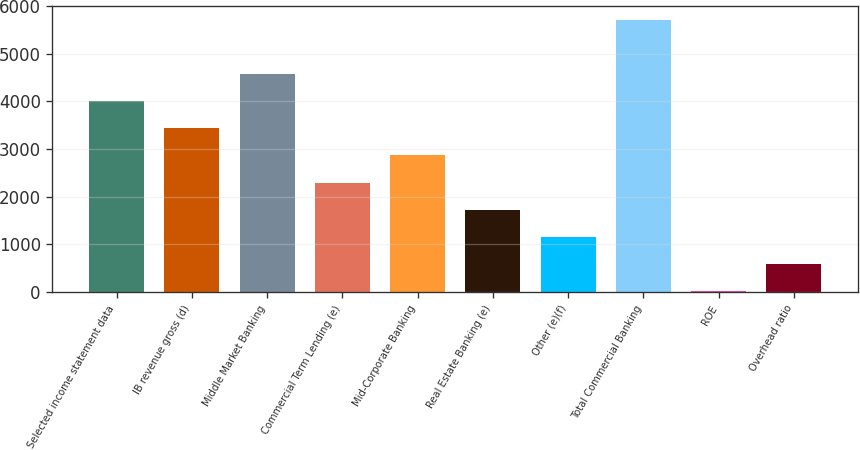Convert chart to OTSL. <chart><loc_0><loc_0><loc_500><loc_500><bar_chart><fcel>Selected income statement data<fcel>IB revenue gross (d)<fcel>Middle Market Banking<fcel>Commercial Term Lending (e)<fcel>Mid-Corporate Banking<fcel>Real Estate Banking (e)<fcel>Other (e)(f)<fcel>Total Commercial Banking<fcel>ROE<fcel>Overhead ratio<nl><fcel>4008.8<fcel>3438.4<fcel>4579.2<fcel>2297.6<fcel>2868<fcel>1727.2<fcel>1156.8<fcel>5720<fcel>16<fcel>586.4<nl></chart> 